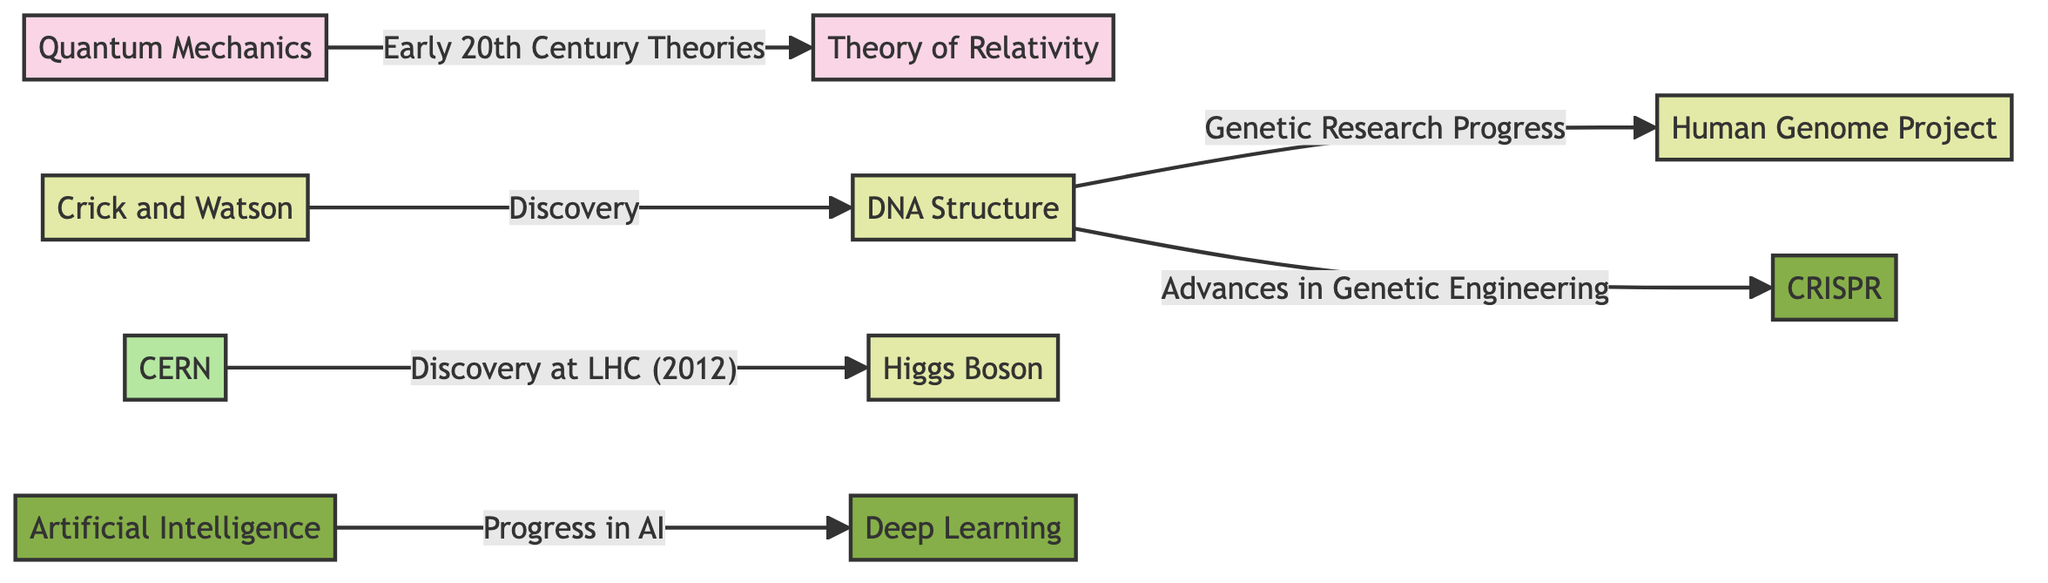What major theory is represented at the top left of the diagram? The diagram shows "Quantum Mechanics" at the top left as a key fundamental theory. It is also connected to the "Theory of Relativity."
Answer: Quantum Mechanics How many discoveries are listed in the diagram? By counting the distinct discovery nodes present, we have "DNA Structure," "Crick and Watson," "Human Genome Project," and "Higgs Boson," totaling four discoveries.
Answer: 4 What organization is associated with the discovery of the Higgs Boson? The "CERN" node directly connects to the "Higgs Boson" node through the edge labeled "Discovery at LHC (2012)," indicating its involvement in this discovery.
Answer: CERN Which technology is linked to advancements in artificial intelligence? The edge from the "Artificial Intelligence" node leads to the "Deep Learning" node, indicating that deep learning is a significant advancement under the umbrella of AI.
Answer: Deep Learning What is the connection between DNA Structure and CRISPR? The edge labeled "Advances in Genetic Engineering" connects the "DNA Structure" node to the "CRISPR" node, indicating that advancements in genetic engineering have led to CRISPR's development.
Answer: Advances in Genetic Engineering What sequence connects Quantum Mechanics and the Theory of Relativity? The flow indicates that "Quantum Mechanics" leads to "Theory of Relativity" under the label "Early 20th Century Theories," showing their sequence related to theoretical development in that era.
Answer: Early 20th Century Theories What is the progression that connects Crick and Watson to DNA Structure? The connection label is "Discovery," illustrating that Crick and Watson's work directly resulted in the understanding of DNA Structure.
Answer: Discovery What year is associated with the discovery at CERN? The label on the edge connecting "CERN" and "Higgs Boson" specifies the year "2012," highlighting when the discovery was confirmed.
Answer: 2012 Which discovery is linked directly to genetic research progress? The edge labeled "Genetic Research Progress" connects "DNA Structure" to "Human Genome Project," showing this direct relationship in the context of genetic advancements.
Answer: Human Genome Project 